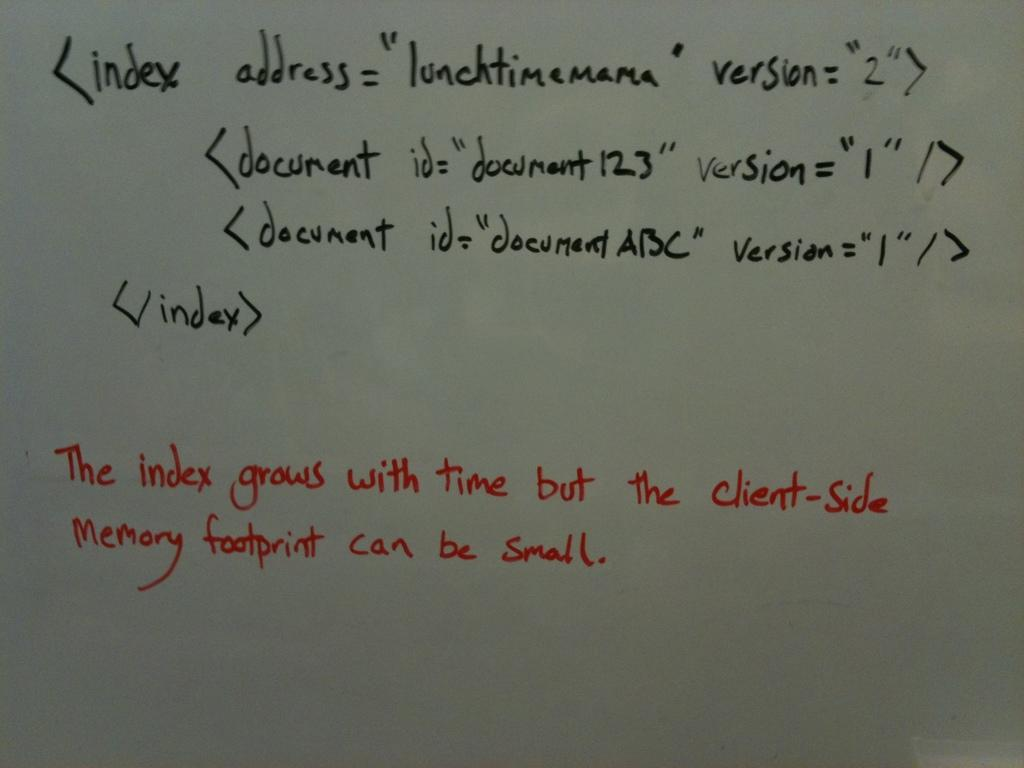<image>
Present a compact description of the photo's key features. Someone has noted that the index grows with time on the whiteboard. 